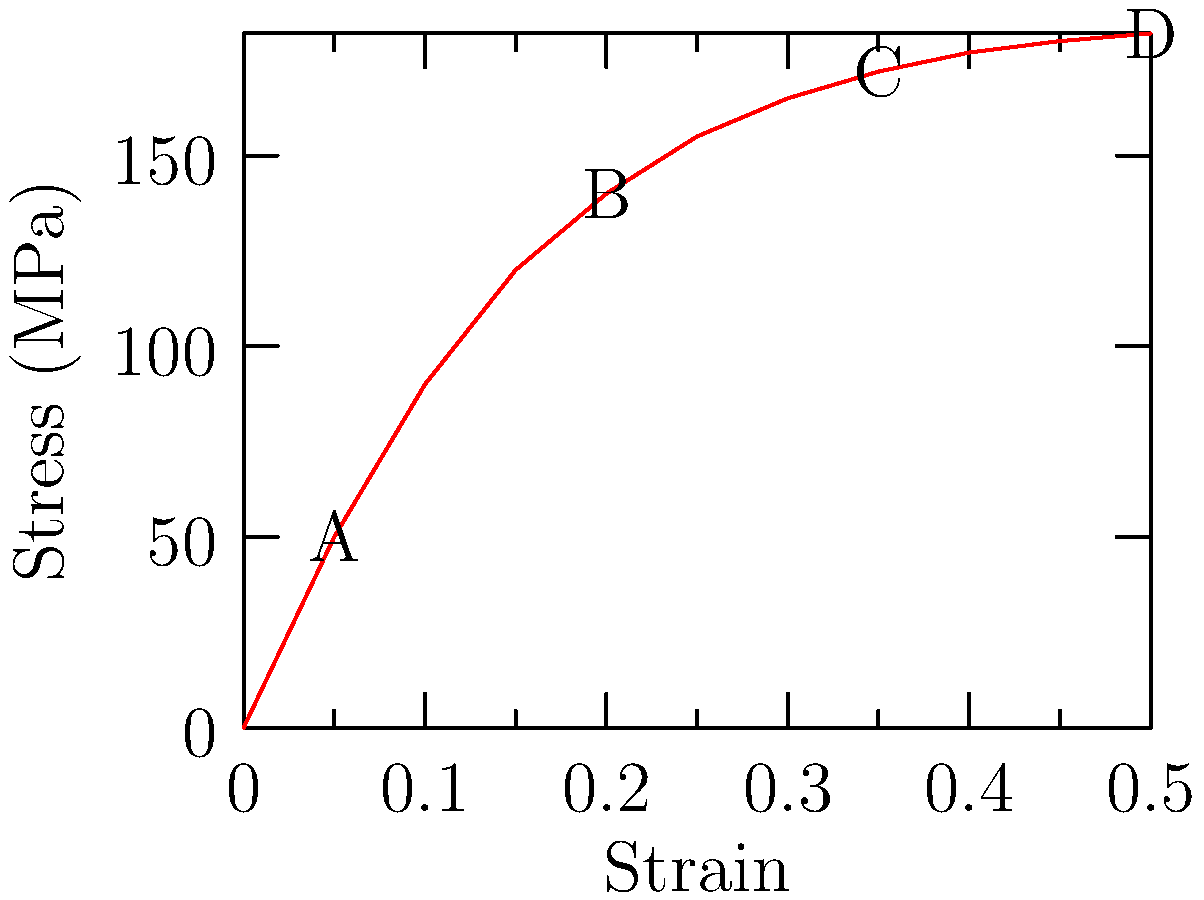Based on the stress-strain curve shown for a basketball shoe material, which region (A-B, B-C, or C-D) would provide the best shock absorption properties for minimizing the risk of injuries during high-impact landings? To determine the best region for shock absorption, we need to consider the material's behavior in each region:

1. Region A-B: This is the linear elastic region. The material deforms proportionally to the applied stress and returns to its original shape when the stress is removed. However, it doesn't absorb much energy.

2. Region B-C: This is the plastic deformation region. The material undergoes permanent deformation and absorbs more energy than the elastic region. However, permanent deformation is not desirable for repeated use.

3. Region C-D: This is the strain hardening region. The material continues to deform but requires increasing stress to do so. This region doesn't provide optimal energy absorption.

For optimal shock absorption in basketball shoes, we want a material that can absorb a large amount of energy without permanent deformation. The ideal region is just before the yield point (end of region A-B), where the material exhibits maximum elastic deformation.

This allows the shoe to:
a) Absorb significant impact energy
b) Return to its original shape after impact
c) Provide consistent performance over multiple uses

Therefore, the best region for shock absorption properties is A-B, specifically near point B, where elastic deformation is maximized without entering the plastic deformation region.
Answer: Region A-B (near point B) 